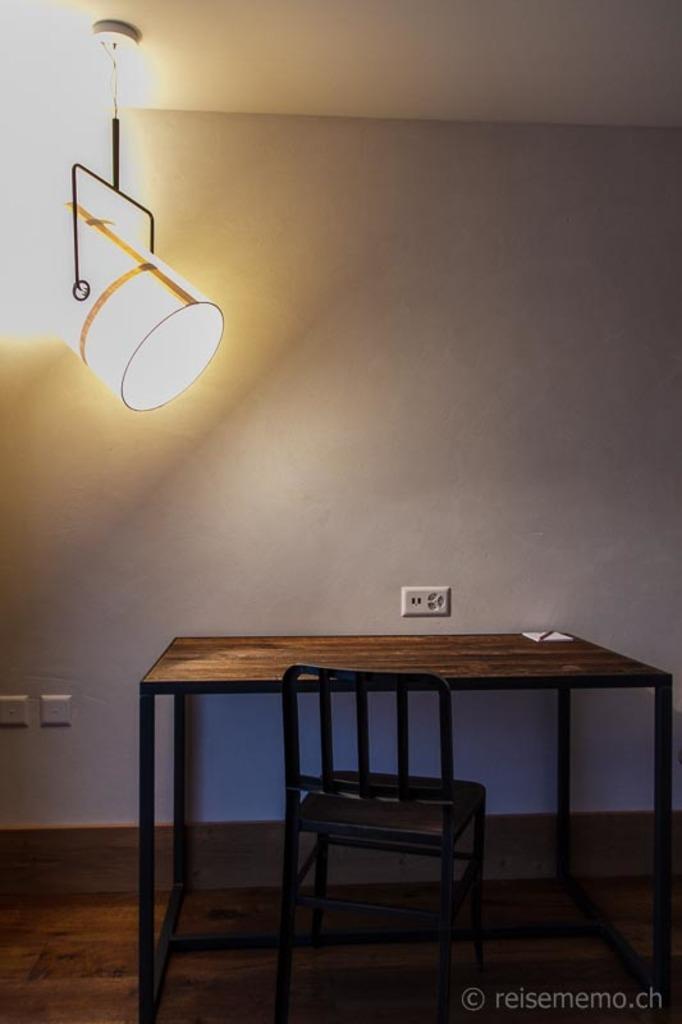Please provide a concise description of this image. In this image we can see there is a table, on the table there is an object. And there is a chair. And at the top there is a light. At the back there is a wall with switch board. 